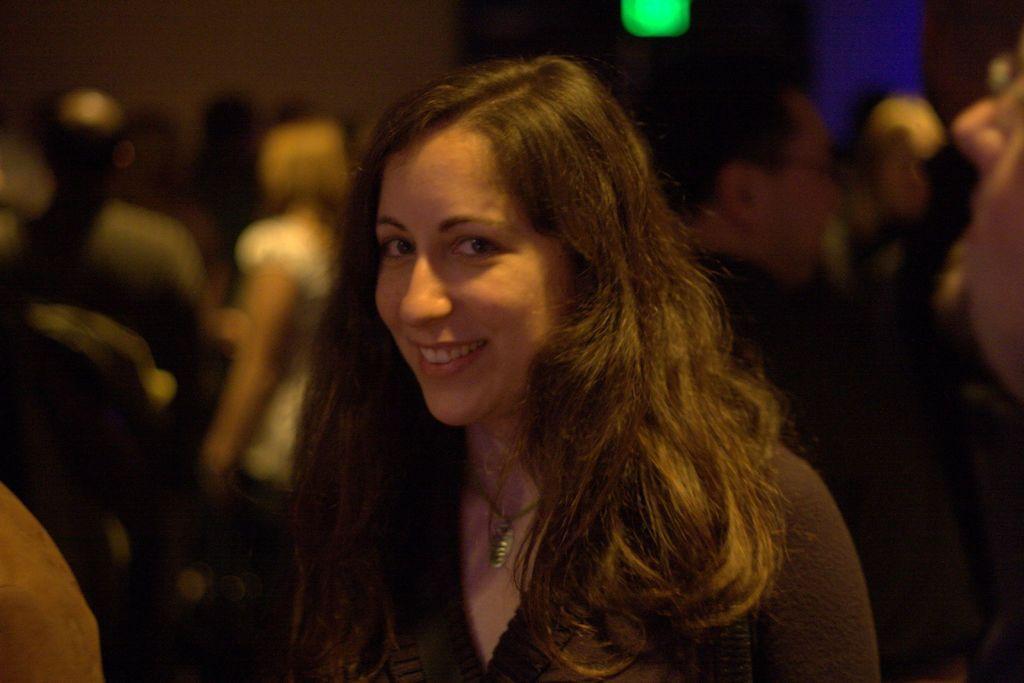Could you give a brief overview of what you see in this image? In this image there is a woman standing, in the background there are people and it is blurred. 